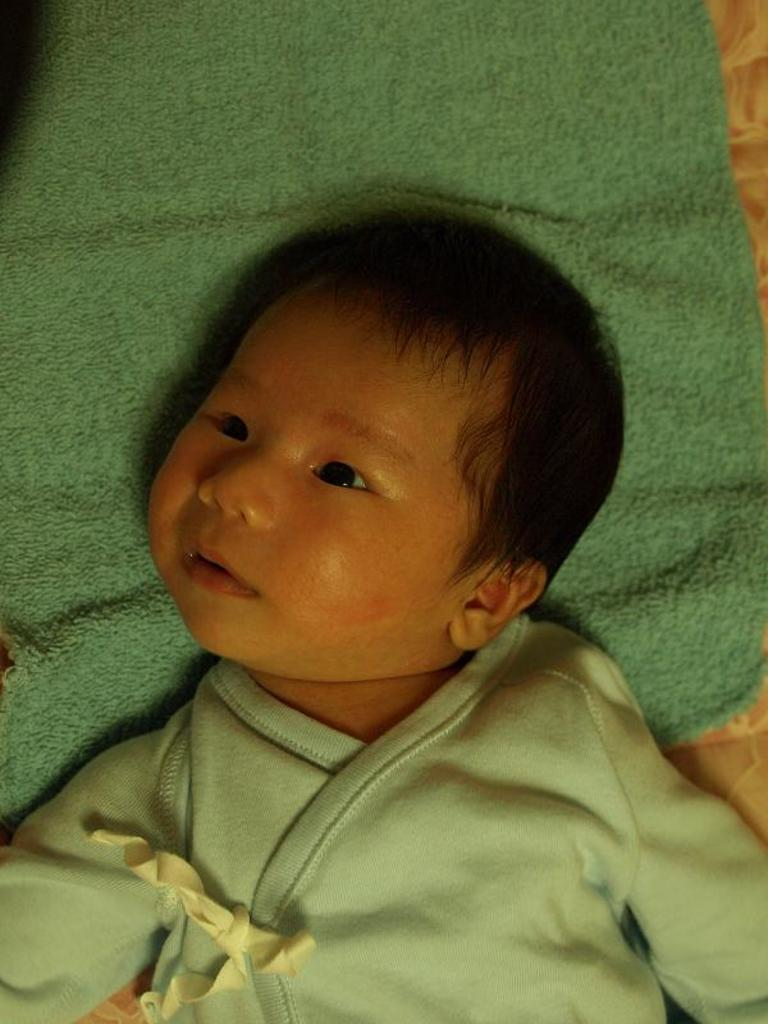What is the main subject of the image? There is a baby in the image. What color is the cloth that is visible in the image? There is a green color cloth in the image. What type of flower is the baby holding in the image? There is no flower present in the image; the baby is not holding anything. 